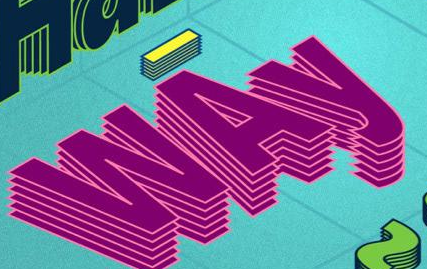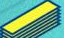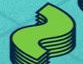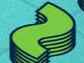Identify the words shown in these images in order, separated by a semicolon. WAy; -; ~; ~ 